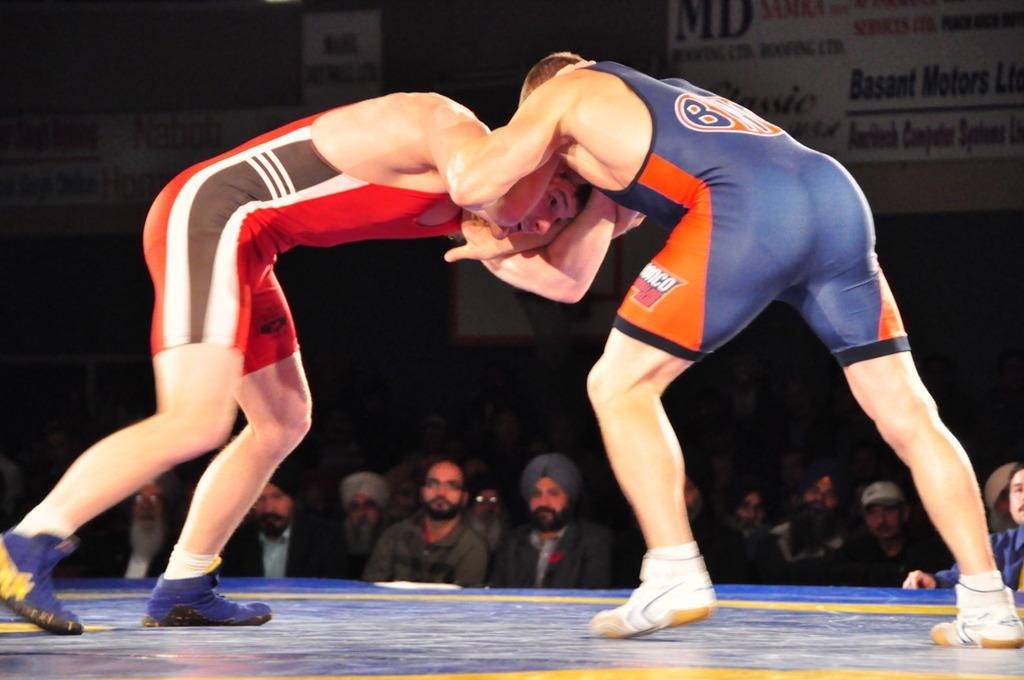<image>
Give a short and clear explanation of the subsequent image. two people are wrestling and the one in the blus is sponsored by sunono 